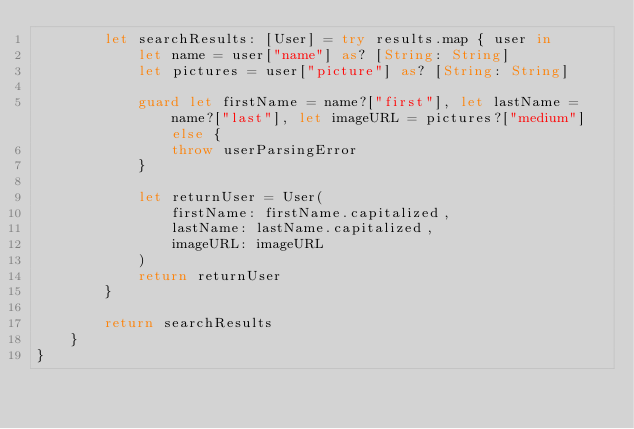Convert code to text. <code><loc_0><loc_0><loc_500><loc_500><_Swift_>        let searchResults: [User] = try results.map { user in
            let name = user["name"] as? [String: String]
            let pictures = user["picture"] as? [String: String]
            
            guard let firstName = name?["first"], let lastName = name?["last"], let imageURL = pictures?["medium"] else {
                throw userParsingError
            }
            
            let returnUser = User(
                firstName: firstName.capitalized,
                lastName: lastName.capitalized,
                imageURL: imageURL
            )
            return returnUser
        }
        
        return searchResults
    }
}
</code> 